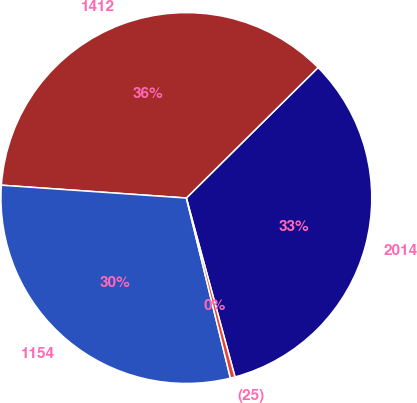<chart> <loc_0><loc_0><loc_500><loc_500><pie_chart><fcel>2014<fcel>1412<fcel>1154<fcel>(25)<nl><fcel>33.2%<fcel>36.47%<fcel>29.92%<fcel>0.41%<nl></chart> 